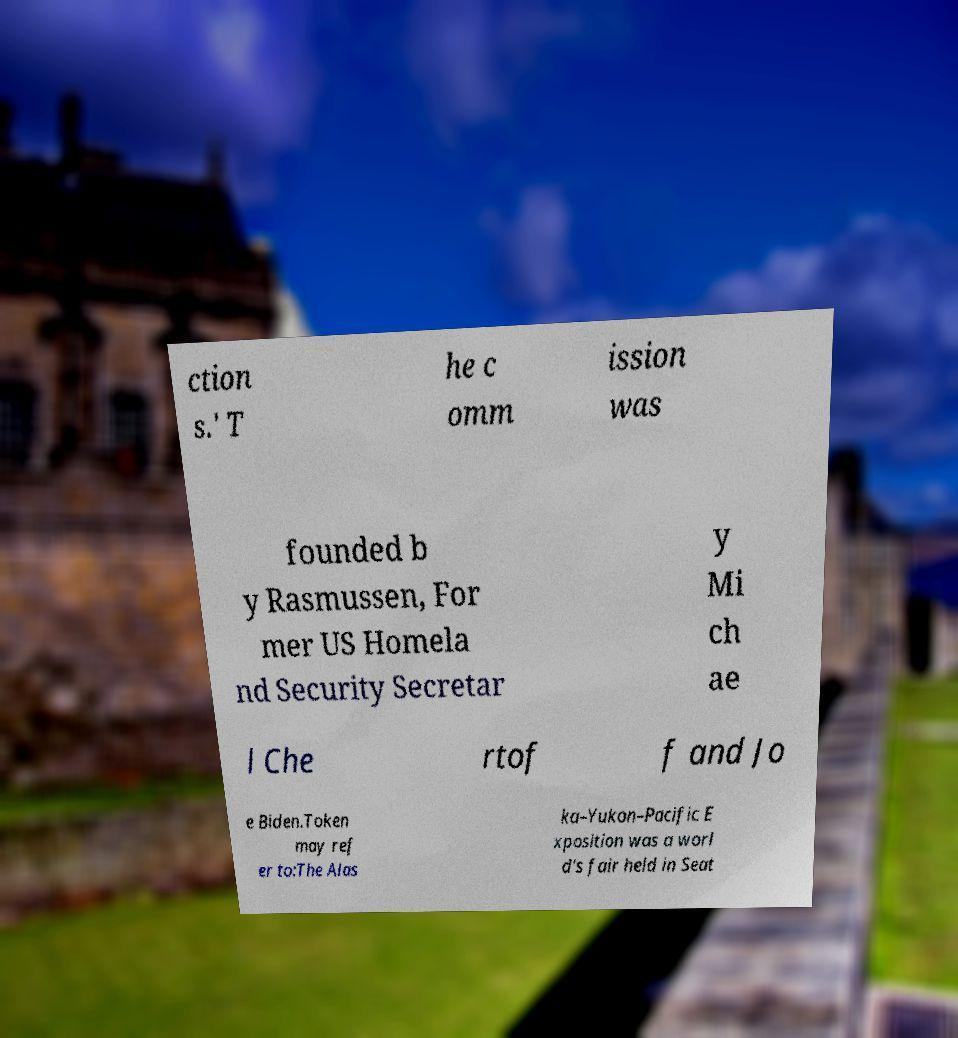What messages or text are displayed in this image? I need them in a readable, typed format. ction s.' T he c omm ission was founded b y Rasmussen, For mer US Homela nd Security Secretar y Mi ch ae l Che rtof f and Jo e Biden.Token may ref er to:The Alas ka–Yukon–Pacific E xposition was a worl d's fair held in Seat 